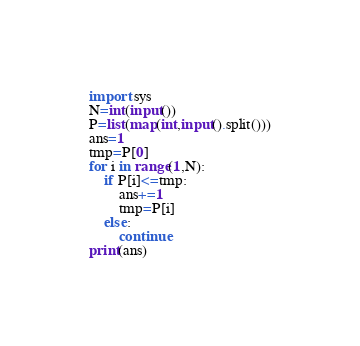<code> <loc_0><loc_0><loc_500><loc_500><_Python_>import sys
N=int(input())
P=list(map(int,input().split()))
ans=1
tmp=P[0]
for i in range(1,N):
    if P[i]<=tmp:
        ans+=1
        tmp=P[i]
    else:
        continue
print(ans)</code> 